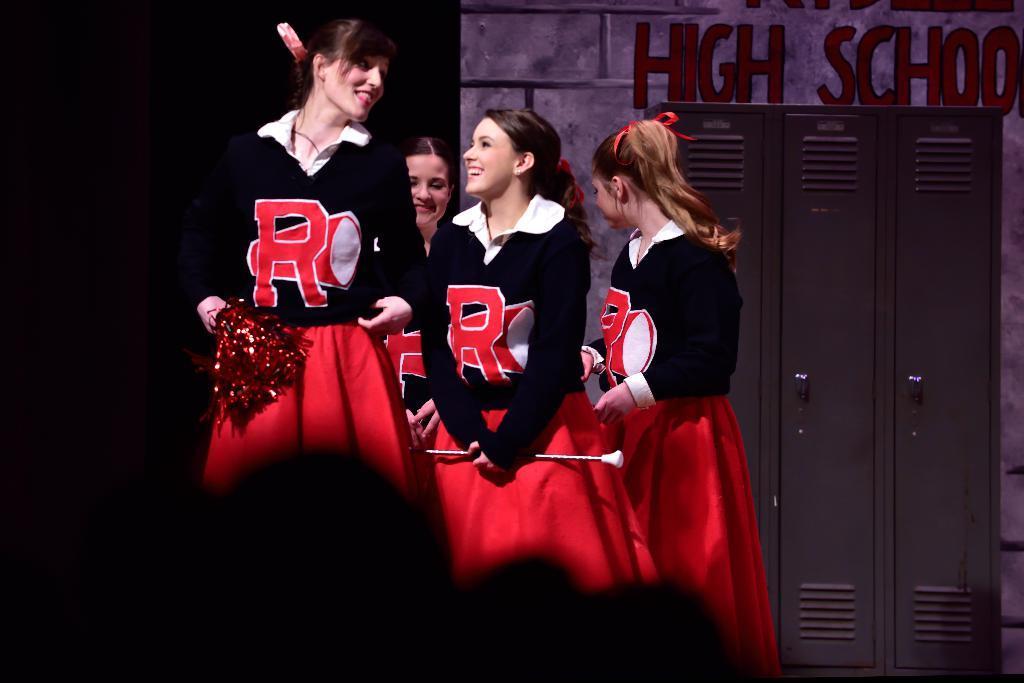Please provide a concise description of this image. In this image there are four women standing, they are holding an object, there is an object towards the bottom of the image, there is a wardrobe, there is a curtain towards the right of the image, there is a wall, there is text on the wall. 